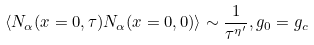<formula> <loc_0><loc_0><loc_500><loc_500>\left \langle N _ { \alpha } ( x = 0 , \tau ) N _ { \alpha } ( x = 0 , 0 ) \right \rangle \sim \frac { 1 } { \tau ^ { \eta ^ { \prime } } } , g _ { 0 } = g _ { c }</formula> 